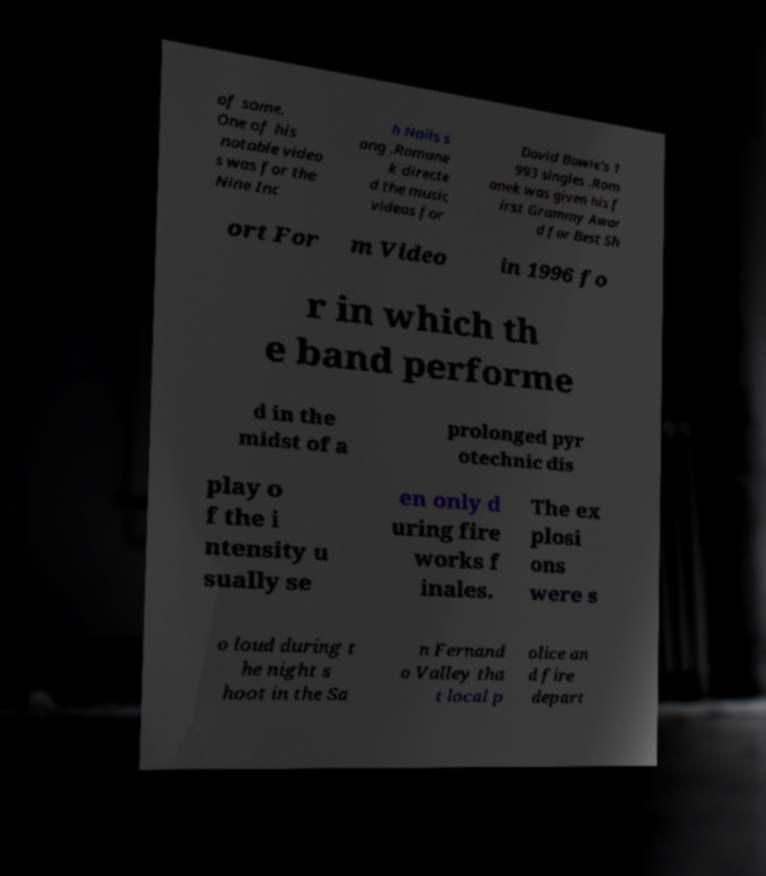Could you extract and type out the text from this image? of some. One of his notable video s was for the Nine Inc h Nails s ong .Romane k directe d the music videos for David Bowie's 1 993 singles .Rom anek was given his f irst Grammy Awar d for Best Sh ort For m Video in 1996 fo r in which th e band performe d in the midst of a prolonged pyr otechnic dis play o f the i ntensity u sually se en only d uring fire works f inales. The ex plosi ons were s o loud during t he night s hoot in the Sa n Fernand o Valley tha t local p olice an d fire depart 